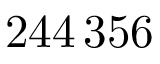Convert formula to latex. <formula><loc_0><loc_0><loc_500><loc_500>2 4 4 \, 3 5 6</formula> 